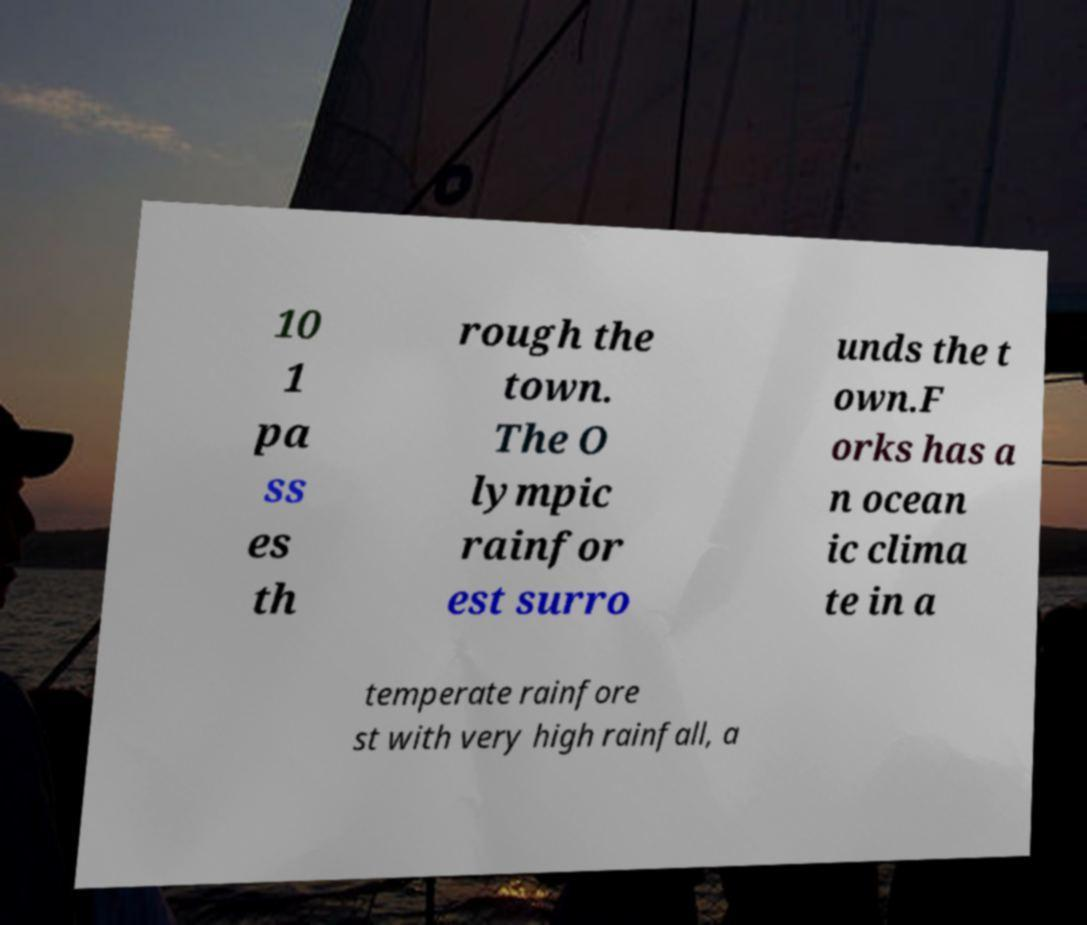Could you assist in decoding the text presented in this image and type it out clearly? 10 1 pa ss es th rough the town. The O lympic rainfor est surro unds the t own.F orks has a n ocean ic clima te in a temperate rainfore st with very high rainfall, a 